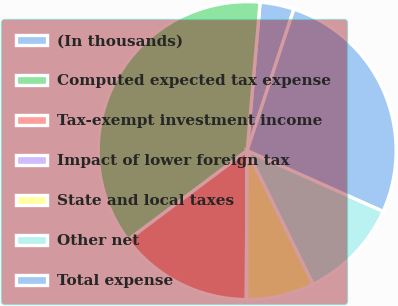Convert chart. <chart><loc_0><loc_0><loc_500><loc_500><pie_chart><fcel>(In thousands)<fcel>Computed expected tax expense<fcel>Tax-exempt investment income<fcel>Impact of lower foreign tax<fcel>State and local taxes<fcel>Other net<fcel>Total expense<nl><fcel>3.7%<fcel>36.62%<fcel>14.67%<fcel>0.04%<fcel>7.36%<fcel>11.01%<fcel>26.6%<nl></chart> 